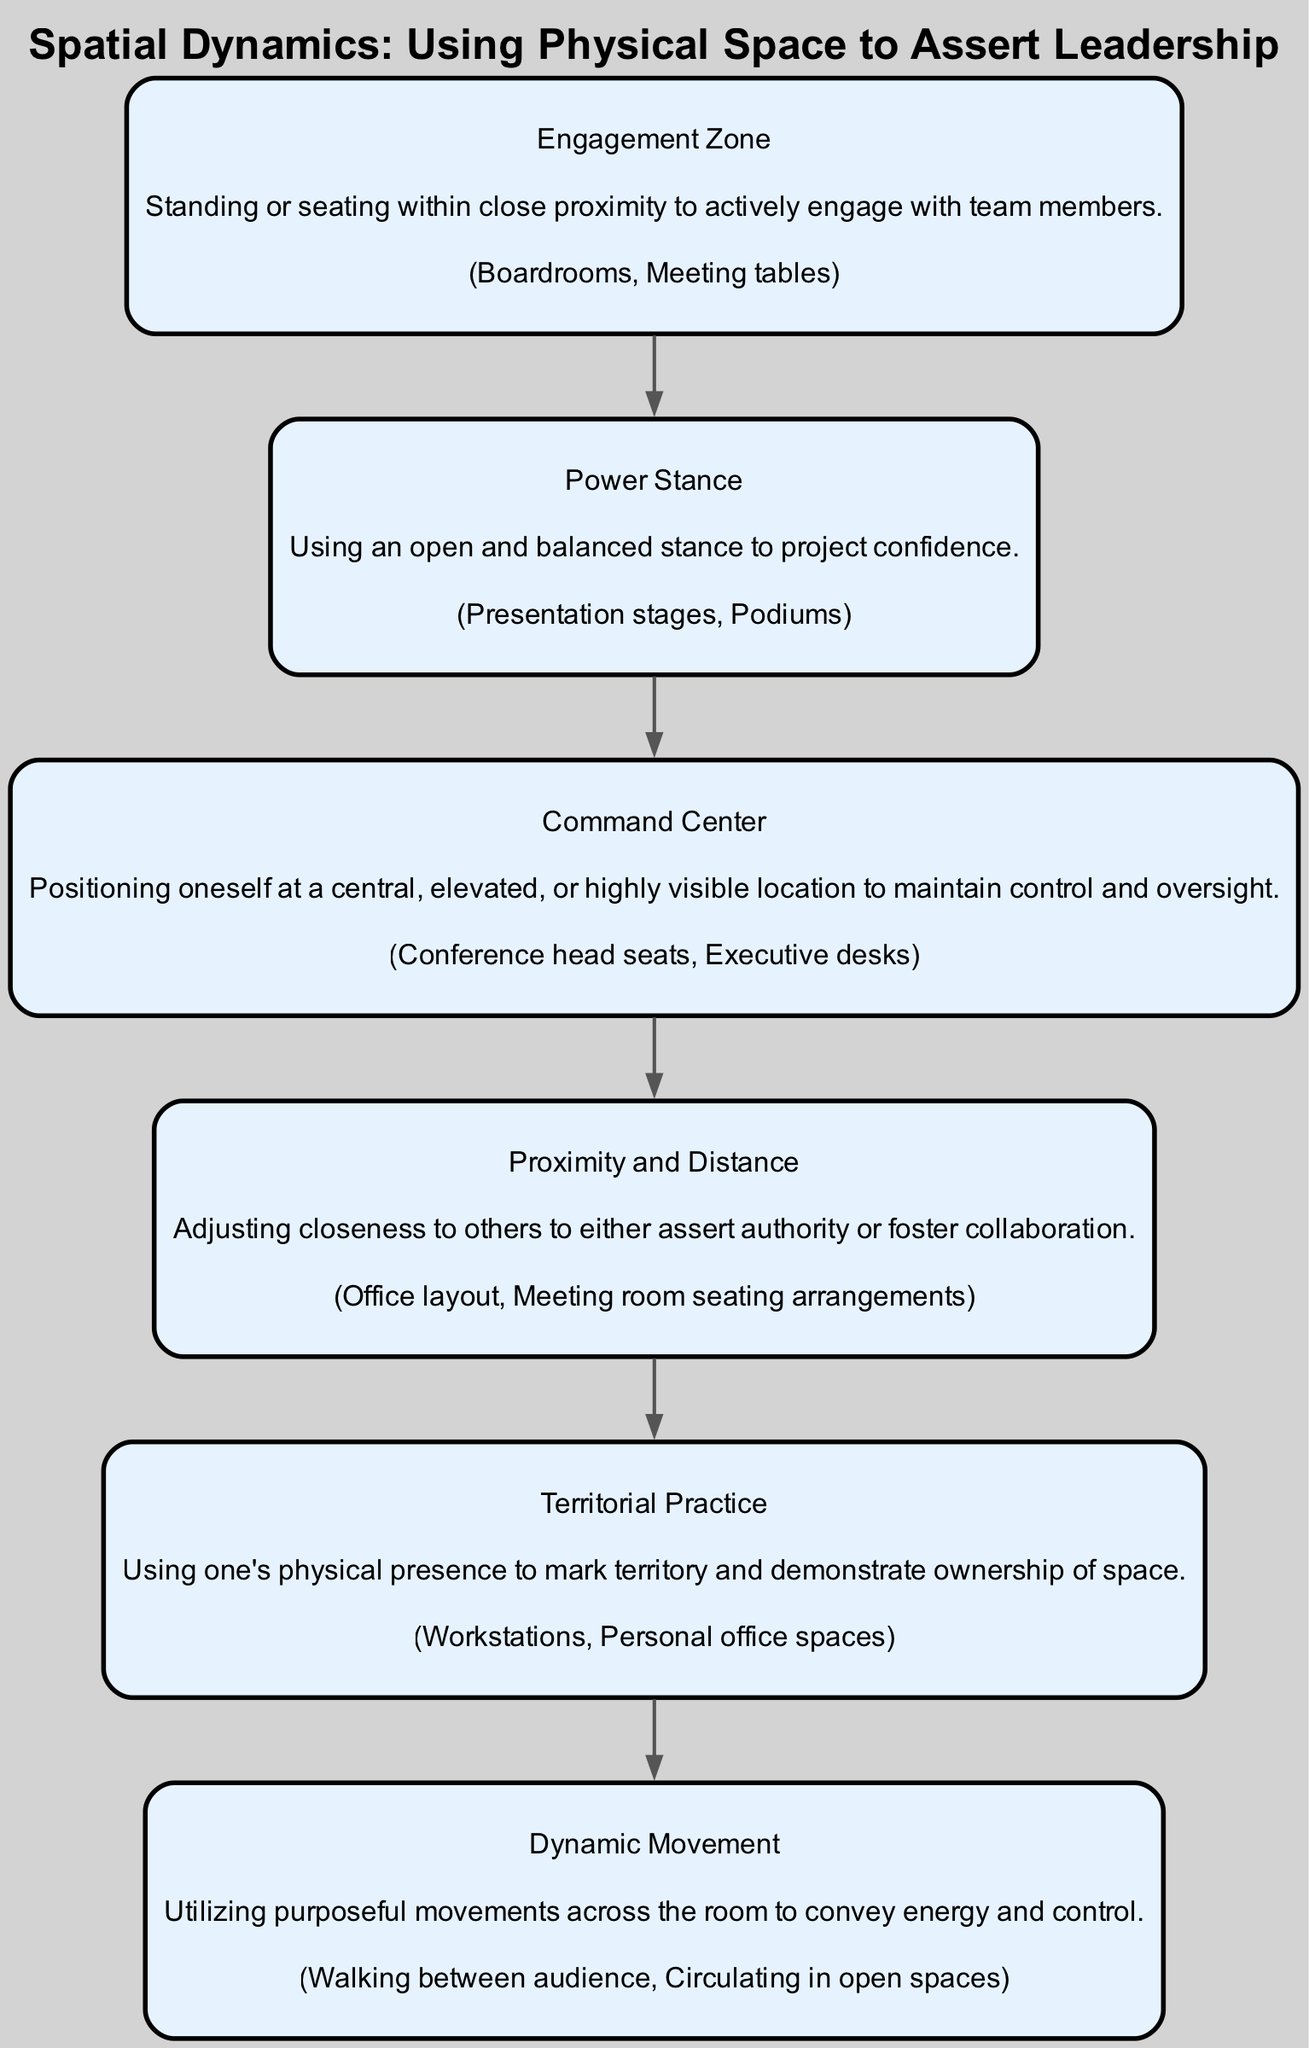What is the title of the clinical pathway? The title of the clinical pathway is located at the top of the diagram and provides the main focus of the pathway.
Answer: Spatial Dynamics: Using Physical Space to Assert Leadership How many key elements are in the diagram? Counting the individual elements within the diagram reveals that there are a total of six key elements listed.
Answer: 6 What is the description of "Power Stance"? "Power Stance" is one of the elements in the diagram, and its description can be found as a text label associated with it.
Answer: Using an open and balanced stance to project confidence What is the real-world entity associated with "Command Center"? Each element in the diagram includes a real-world entity. For "Command Center," identifying this will lead to its listed association.
Answer: Conference head seats, Executive desks How does "Engagement Zone" relate to "Proximity and Distance"? To answer this, we trace the flow of the diagram from "Engagement Zone" to "Proximity and Distance," noting that both elements concern physical positioning and interaction with others.
Answer: Both focus on how closeness affects engagement and authority dynamics Describe the primary difference between "Territorial Practice" and "Dynamic Movement." By analyzing the descriptions of both elements, we can identify their core functions: one focuses on marking territory while the other emphasizes energy in movement.
Answer: Territorial Practice is about marking space; Dynamic Movement is about energetic movement across the room 